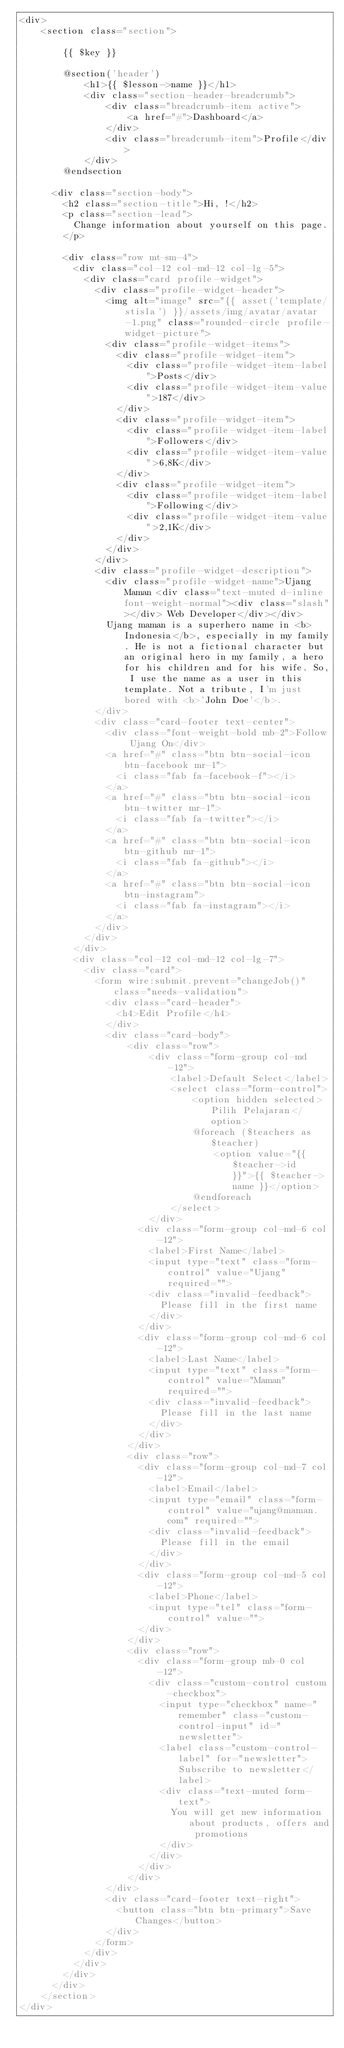Convert code to text. <code><loc_0><loc_0><loc_500><loc_500><_PHP_><div>
    <section class="section">

        {{ $key }}
      
        @section('header')
            <h1>{{ $lesson->name }}</h1>
            <div class="section-header-breadcrumb">
                <div class="breadcrumb-item active">
                    <a href="#">Dashboard</a>
                </div>
                <div class="breadcrumb-item">Profile</div>
            </div>
        @endsection

      <div class="section-body">
        <h2 class="section-title">Hi, !</h2>
        <p class="section-lead">
          Change information about yourself on this page.
        </p>

        <div class="row mt-sm-4">
          <div class="col-12 col-md-12 col-lg-5">
            <div class="card profile-widget">
              <div class="profile-widget-header">
                <img alt="image" src="{{ asset('template/stisla') }}/assets/img/avatar/avatar-1.png" class="rounded-circle profile-widget-picture">
                <div class="profile-widget-items">
                  <div class="profile-widget-item">
                    <div class="profile-widget-item-label">Posts</div>
                    <div class="profile-widget-item-value">187</div>
                  </div>
                  <div class="profile-widget-item">
                    <div class="profile-widget-item-label">Followers</div>
                    <div class="profile-widget-item-value">6,8K</div>
                  </div>
                  <div class="profile-widget-item">
                    <div class="profile-widget-item-label">Following</div>
                    <div class="profile-widget-item-value">2,1K</div>
                  </div>
                </div>
              </div>
              <div class="profile-widget-description">
                <div class="profile-widget-name">Ujang Maman <div class="text-muted d-inline font-weight-normal"><div class="slash"></div> Web Developer</div></div>
                Ujang maman is a superhero name in <b>Indonesia</b>, especially in my family. He is not a fictional character but an original hero in my family, a hero for his children and for his wife. So, I use the name as a user in this template. Not a tribute, I'm just bored with <b>'John Doe'</b>.
              </div>
              <div class="card-footer text-center">
                <div class="font-weight-bold mb-2">Follow Ujang On</div>
                <a href="#" class="btn btn-social-icon btn-facebook mr-1">
                  <i class="fab fa-facebook-f"></i>
                </a>
                <a href="#" class="btn btn-social-icon btn-twitter mr-1">
                  <i class="fab fa-twitter"></i>
                </a>
                <a href="#" class="btn btn-social-icon btn-github mr-1">
                  <i class="fab fa-github"></i>
                </a>
                <a href="#" class="btn btn-social-icon btn-instagram">
                  <i class="fab fa-instagram"></i>
                </a>
              </div>
            </div>
          </div>
          <div class="col-12 col-md-12 col-lg-7">
            <div class="card">
              <form wire:submit.prevent="changeJob()" class="needs-validation">
                <div class="card-header">
                  <h4>Edit Profile</h4>
                </div>
                <div class="card-body">
                    <div class="row">
                        <div class="form-group col-md-12">
                            <label>Default Select</label>
                            <select class="form-control">
                                <option hidden selected>Pilih Pelajaran</option>
                                @foreach ($teachers as $teacher)
                                    <option value="{{ $teacher->id }}">{{ $teacher->name }}</option>
                                @endforeach
                            </select>
                        </div>
                      <div class="form-group col-md-6 col-12">
                        <label>First Name</label>
                        <input type="text" class="form-control" value="Ujang" required="">
                        <div class="invalid-feedback">
                          Please fill in the first name
                        </div>
                      </div>
                      <div class="form-group col-md-6 col-12">
                        <label>Last Name</label>
                        <input type="text" class="form-control" value="Maman" required="">
                        <div class="invalid-feedback">
                          Please fill in the last name
                        </div>
                      </div>
                    </div>
                    <div class="row">
                      <div class="form-group col-md-7 col-12">
                        <label>Email</label>
                        <input type="email" class="form-control" value="ujang@maman.com" required="">
                        <div class="invalid-feedback">
                          Please fill in the email
                        </div>
                      </div>
                      <div class="form-group col-md-5 col-12">
                        <label>Phone</label>
                        <input type="tel" class="form-control" value="">
                      </div>
                    </div>
                    <div class="row">
                      <div class="form-group mb-0 col-12">
                        <div class="custom-control custom-checkbox">
                          <input type="checkbox" name="remember" class="custom-control-input" id="newsletter">
                          <label class="custom-control-label" for="newsletter">Subscribe to newsletter</label>
                          <div class="text-muted form-text">
                            You will get new information about products, offers and promotions
                          </div>
                        </div>
                      </div>
                    </div>
                </div>
                <div class="card-footer text-right">
                  <button class="btn btn-primary">Save Changes</button>
                </div>
              </form>
            </div>
          </div>
        </div>
      </div>
    </section>
</div>
</code> 